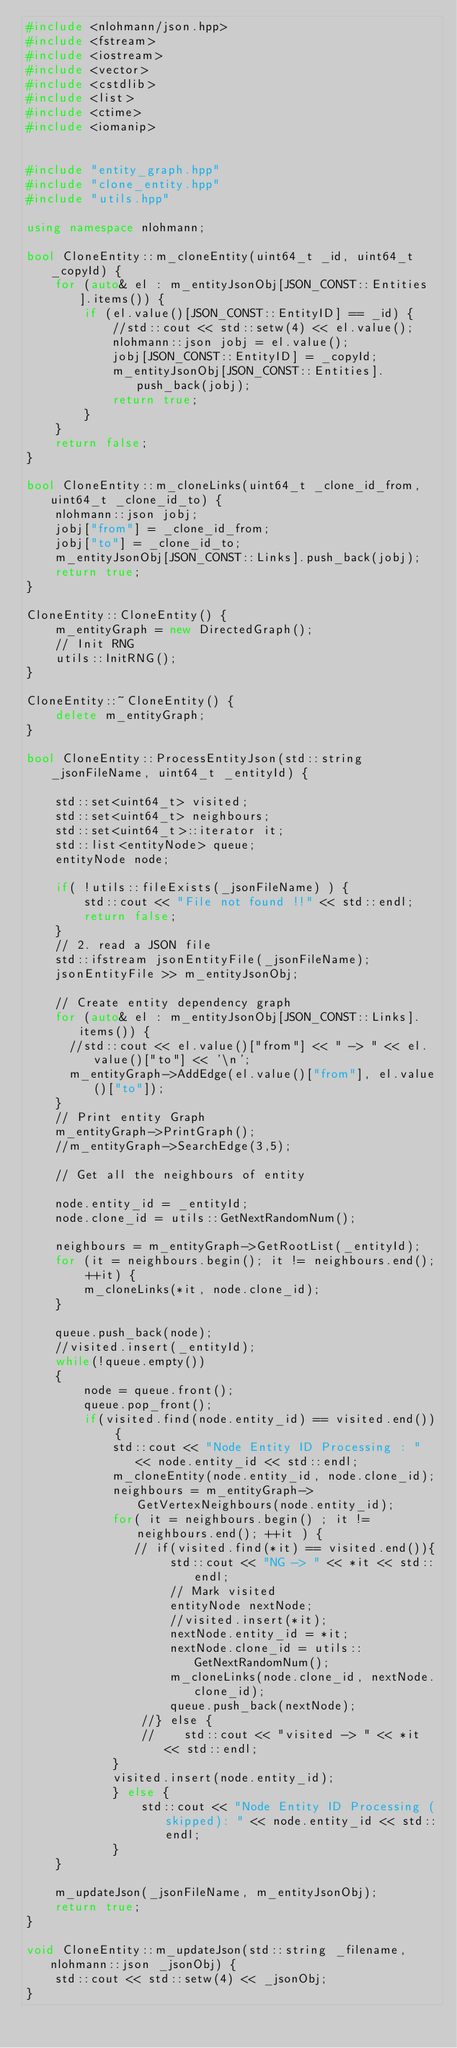<code> <loc_0><loc_0><loc_500><loc_500><_C++_>#include <nlohmann/json.hpp>
#include <fstream>
#include <iostream>
#include <vector>
#include <cstdlib>
#include <list>
#include <ctime>
#include <iomanip>


#include "entity_graph.hpp"
#include "clone_entity.hpp"
#include "utils.hpp"

using namespace nlohmann;

bool CloneEntity::m_cloneEntity(uint64_t _id, uint64_t _copyId) {
    for (auto& el : m_entityJsonObj[JSON_CONST::Entities].items()) {
        if (el.value()[JSON_CONST::EntityID] == _id) {
            //std::cout << std::setw(4) << el.value();
            nlohmann::json jobj = el.value();
            jobj[JSON_CONST::EntityID] = _copyId;
            m_entityJsonObj[JSON_CONST::Entities].push_back(jobj);
            return true;
        }
    }
    return false;
}

bool CloneEntity::m_cloneLinks(uint64_t _clone_id_from, uint64_t _clone_id_to) {
    nlohmann::json jobj;
    jobj["from"] = _clone_id_from;
    jobj["to"] = _clone_id_to;
    m_entityJsonObj[JSON_CONST::Links].push_back(jobj);
    return true;
}

CloneEntity::CloneEntity() {
    m_entityGraph = new DirectedGraph();
    // Init RNG
    utils::InitRNG();
}

CloneEntity::~CloneEntity() {
    delete m_entityGraph;
}

bool CloneEntity::ProcessEntityJson(std::string _jsonFileName, uint64_t _entityId) {

    std::set<uint64_t> visited;
    std::set<uint64_t> neighbours;
    std::set<uint64_t>::iterator it;
    std::list<entityNode> queue;
    entityNode node;

    if( !utils::fileExists(_jsonFileName) ) {
        std::cout << "File not found !!" << std::endl;
        return false;
    }
    // 2. read a JSON file
    std::ifstream jsonEntityFile(_jsonFileName);
    jsonEntityFile >> m_entityJsonObj;

    // Create entity dependency graph
    for (auto& el : m_entityJsonObj[JSON_CONST::Links].items()) {
      //std::cout << el.value()["from"] << " -> " << el.value()["to"] << '\n';
      m_entityGraph->AddEdge(el.value()["from"], el.value()["to"]);
    }
    // Print entity Graph
    m_entityGraph->PrintGraph();
    //m_entityGraph->SearchEdge(3,5);

    // Get all the neighbours of entity

    node.entity_id = _entityId;
    node.clone_id = utils::GetNextRandomNum();

    neighbours = m_entityGraph->GetRootList(_entityId);
    for (it = neighbours.begin(); it != neighbours.end(); ++it) {
        m_cloneLinks(*it, node.clone_id);
    }

    queue.push_back(node);
    //visited.insert(_entityId);
    while(!queue.empty())
    {
        node = queue.front();
        queue.pop_front();
        if(visited.find(node.entity_id) == visited.end()) {
            std::cout << "Node Entity ID Processing : " << node.entity_id << std::endl;
            m_cloneEntity(node.entity_id, node.clone_id);
            neighbours = m_entityGraph->GetVertexNeighbours(node.entity_id);
            for( it = neighbours.begin() ; it != neighbours.end(); ++it ) {
               // if(visited.find(*it) == visited.end()){
                    std::cout << "NG -> " << *it << std::endl;
                    // Mark visited
                    entityNode nextNode;
                    //visited.insert(*it);
                    nextNode.entity_id = *it;
                    nextNode.clone_id = utils::GetNextRandomNum();
                    m_cloneLinks(node.clone_id, nextNode.clone_id);
                    queue.push_back(nextNode);
                //} else {
                //    std::cout << "visited -> " << *it << std::endl;
            }
            visited.insert(node.entity_id);
            } else {
                std::cout << "Node Entity ID Processing (skipped): " << node.entity_id << std::endl;
            }
    }

    m_updateJson(_jsonFileName, m_entityJsonObj);
    return true;
}

void CloneEntity::m_updateJson(std::string _filename, nlohmann::json _jsonObj) {
    std::cout << std::setw(4) << _jsonObj;
}
</code> 